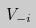<formula> <loc_0><loc_0><loc_500><loc_500>V _ { - i }</formula> 